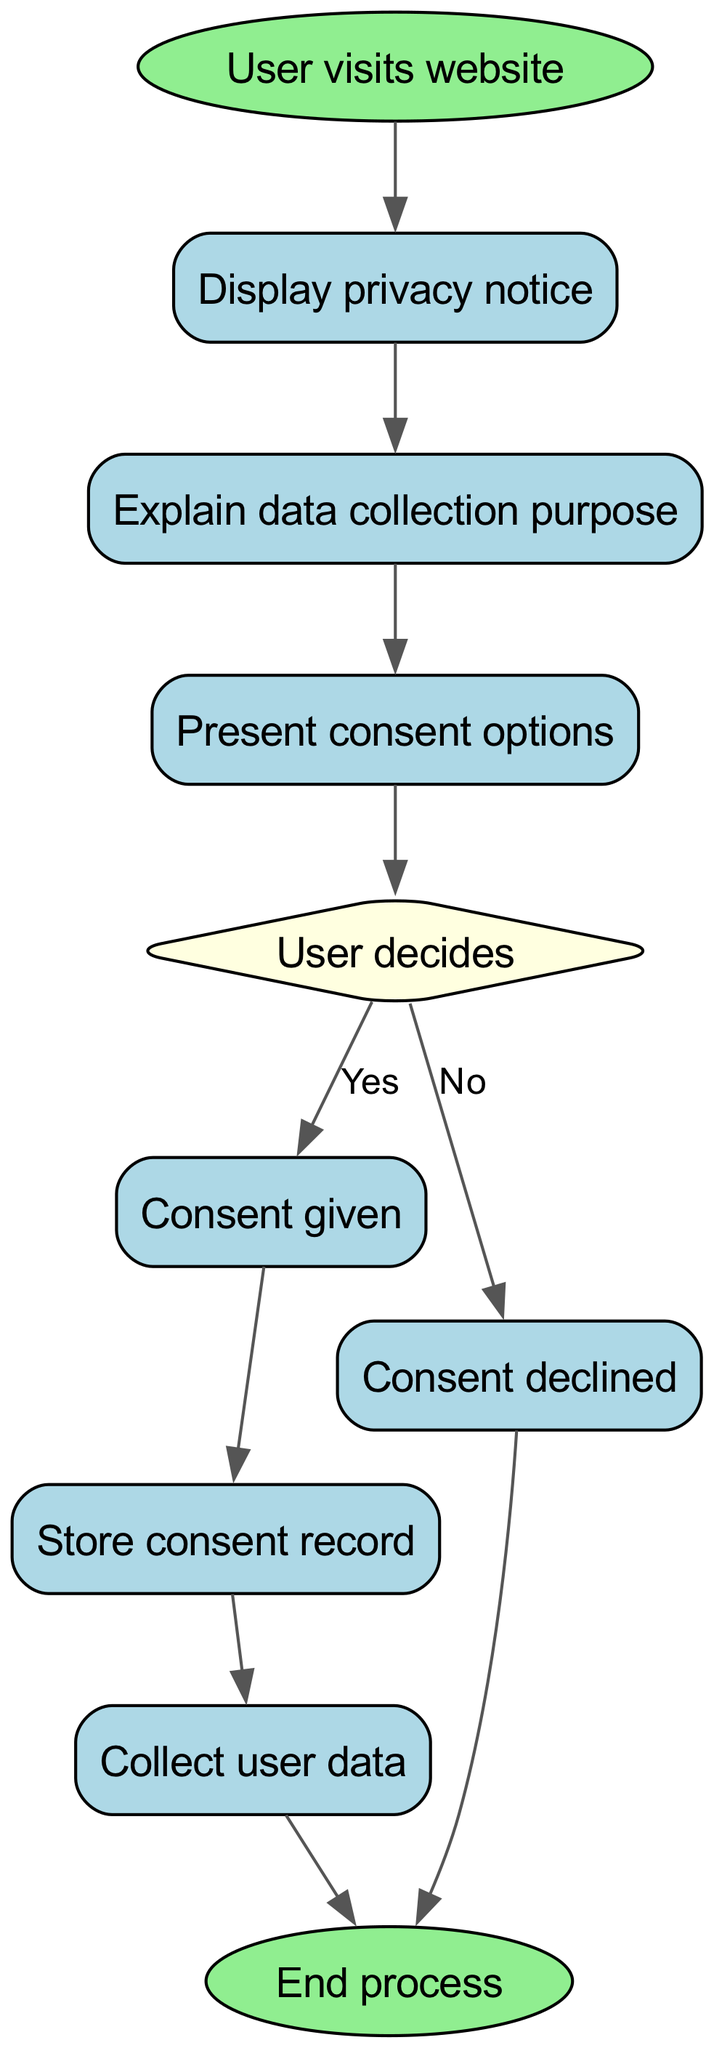What is the first step in the process? The first step is represented by the node labeled "User visits website". This is where the flowchart begins the process of obtaining user consent for data collection.
Answer: User visits website How many nodes are there in the diagram? By counting each distinct step represented by the nodes in the flowchart, we find there are 10 nodes total. These include various steps from the start to the end of the process.
Answer: 10 What is the decision that the user must make? The decision is represented in the diamond-shaped node labeled "User decides", where the user has to make a choice about consent.
Answer: User decides What happens after consent is given? After the "Consent given" node, the next action depicted is "Store consent record", meaning the consent information is recorded for future reference.
Answer: Store consent record What are the two possible outcomes after the user decides? The two outcomes are "Consent given" and "Consent declined", which are the possible paths that can be taken based on the user's decision in the flowchart.
Answer: Consent given, Consent declined If consent is declined, what is the next step? If consent is declined, the flowchart indicates that the next step is to go directly to the "End process" node, effectively concluding the consent procedure without collecting data.
Answer: End process Which node describes the need to inform the user about data collection? The node labeled "Explain data collection purpose" directly describes the necessity to inform the user of why their data is being collected.
Answer: Explain data collection purpose In the flowchart, what is the last step? The last step in the flowchart is represented by the node labeled "End process", which concludes the entire procedure of obtaining user consent.
Answer: End process What is displayed before presenting consent options? Before presenting the consent options, the "Display privacy notice" node is shown, indicating that users are first informed of the privacy policy.
Answer: Display privacy notice 